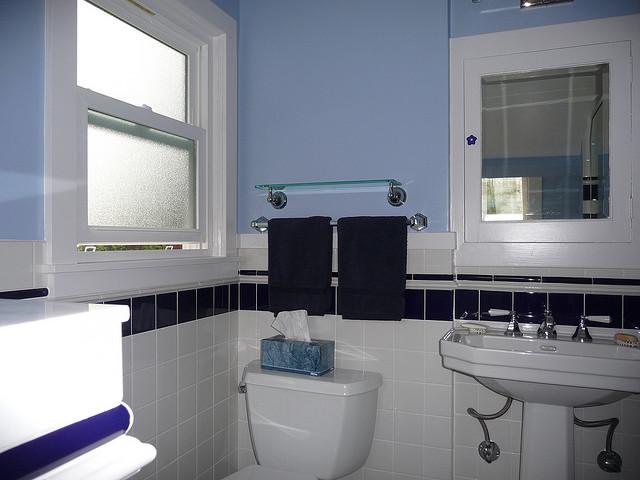Is the window open?
Write a very short answer. Yes. What color is the wall?
Quick response, please. Blue. How many towels are hanging on the rack?
Be succinct. 2. 